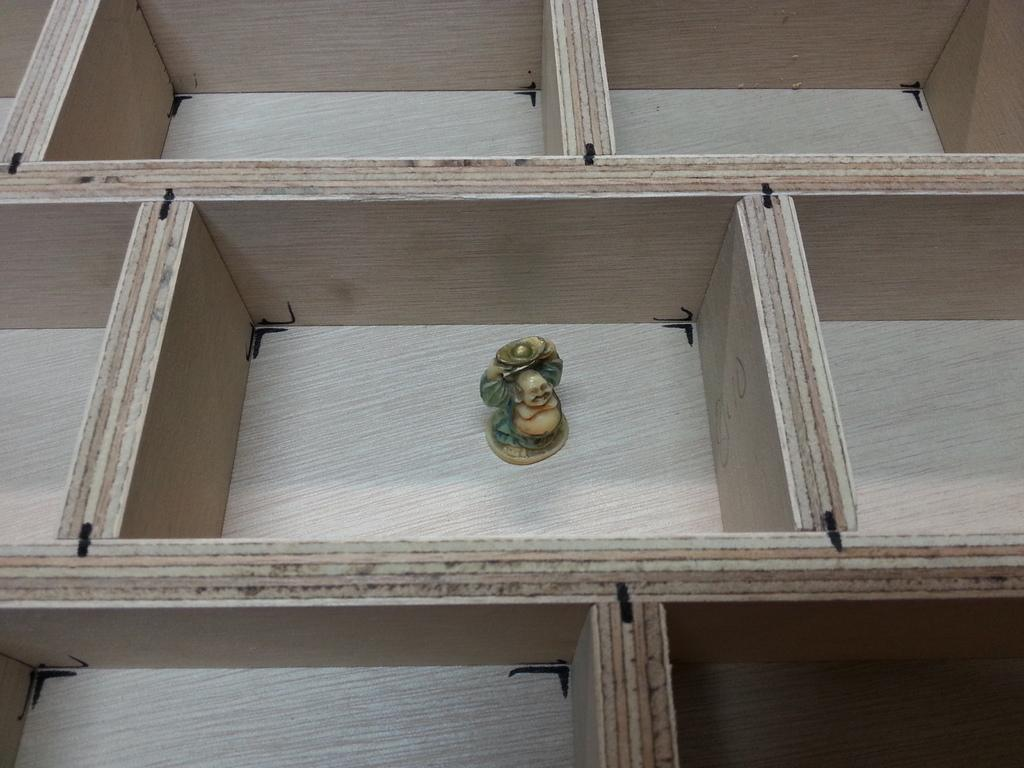What type of structure is present in the image? There is a wooden frame in the image. What can be found within the wooden frame? There are shelves in the image. What is placed on one of the shelves? There is a statue on one of the shelves. What type of fasteners are visible in the image? There are black color clips in the image. What type of stove is visible in the image? There is no stove present in the image. What color is the paint used on the statue in the image? The provided facts do not mention the color of the statue or any paint used on it. 